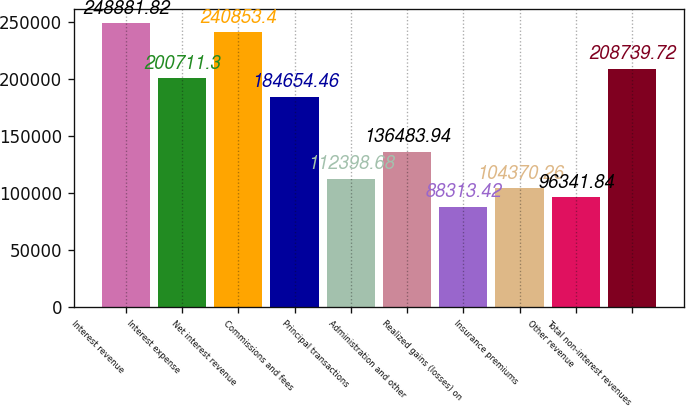Convert chart to OTSL. <chart><loc_0><loc_0><loc_500><loc_500><bar_chart><fcel>Interest revenue<fcel>Interest expense<fcel>Net interest revenue<fcel>Commissions and fees<fcel>Principal transactions<fcel>Administration and other<fcel>Realized gains (losses) on<fcel>Insurance premiums<fcel>Other revenue<fcel>Total non-interest revenues<nl><fcel>248882<fcel>200711<fcel>240853<fcel>184654<fcel>112399<fcel>136484<fcel>88313.4<fcel>104370<fcel>96341.8<fcel>208740<nl></chart> 